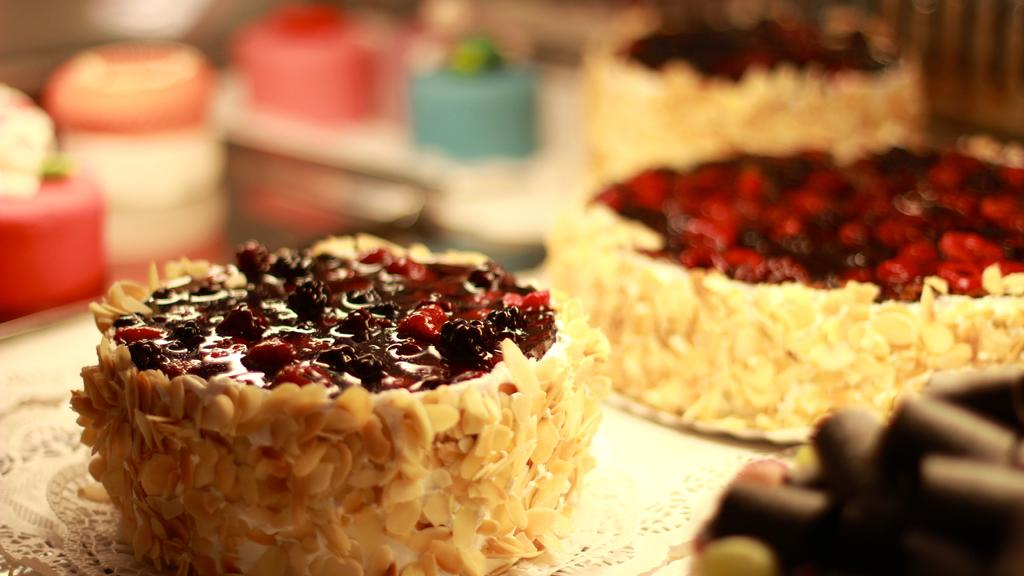What is the focus of the image? The image is zoomed in, so the focus is on a specific area or subject. What can be seen in the background of the image? There are cupcakes and items placed on a table in the background of the image. Who is the expert in the image? There is no expert present in the image. Can you tell me the credit score of the person in the image? There is no person in the image, and therefore no credit score can be determined. 